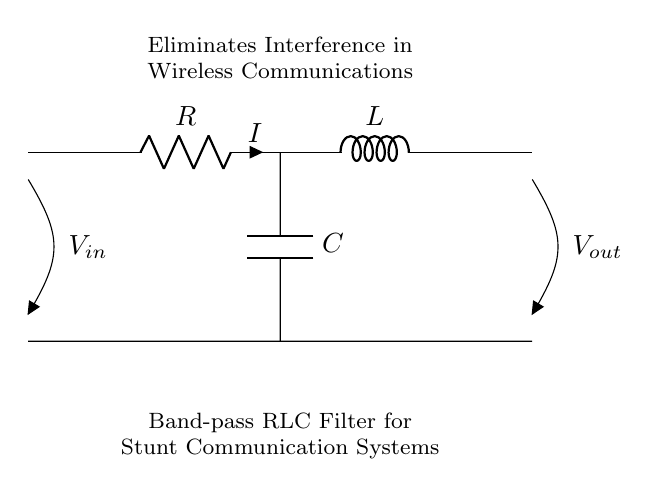What components are present in the circuit? The circuit contains a resistor, an inductor, and a capacitor. Looking at the diagram, we can identify these components based on their symbols and labels. The resistor is denoted as R, the inductor as L, and the capacitor as C.
Answer: Resistor, Inductor, Capacitor What is the input voltage denoted in the circuit? The input voltage is marked as V_in in the diagram. The symbol is displayed at the top left of the circuit, indicating where the voltage is applied.
Answer: V_in What type of filter does this circuit represent? The circuit is a band-pass filter, which is indicated in the text within the diagram. Band-pass filters are designed to allow a specific range of frequencies to pass while attenuating others.
Answer: Band-pass filter What is the significance of using this filter in wireless communication systems? The significance is that it eliminates interference, as stated in the diagram. By allowing only certain frequency ranges to pass, the filter enhances signal quality, which is crucial in communications during stunts.
Answer: Eliminates interference Which component primarily regulates the current flow in this RLC circuit? The component that primarily regulates current flow is the resistor. In an RLC circuit, the resistor introduces resistance that impacts the current as per Ohm's law, influencing overall circuit behavior.
Answer: Resistor What happens to frequencies that are outside the passband of this filter? Frequencies outside the passband of the filter will be attenuated or blocked. This behavior is characteristic of band-pass filters which selectively allow certain frequencies to pass while rejecting others.
Answer: Attenuated or blocked What is the role of the inductor in this circuit? The inductor stores energy in a magnetic field when current flows through it. In RLC circuits, it plays a critical role in determining the frequency response along with the capacitor and resistor.
Answer: Stores energy 